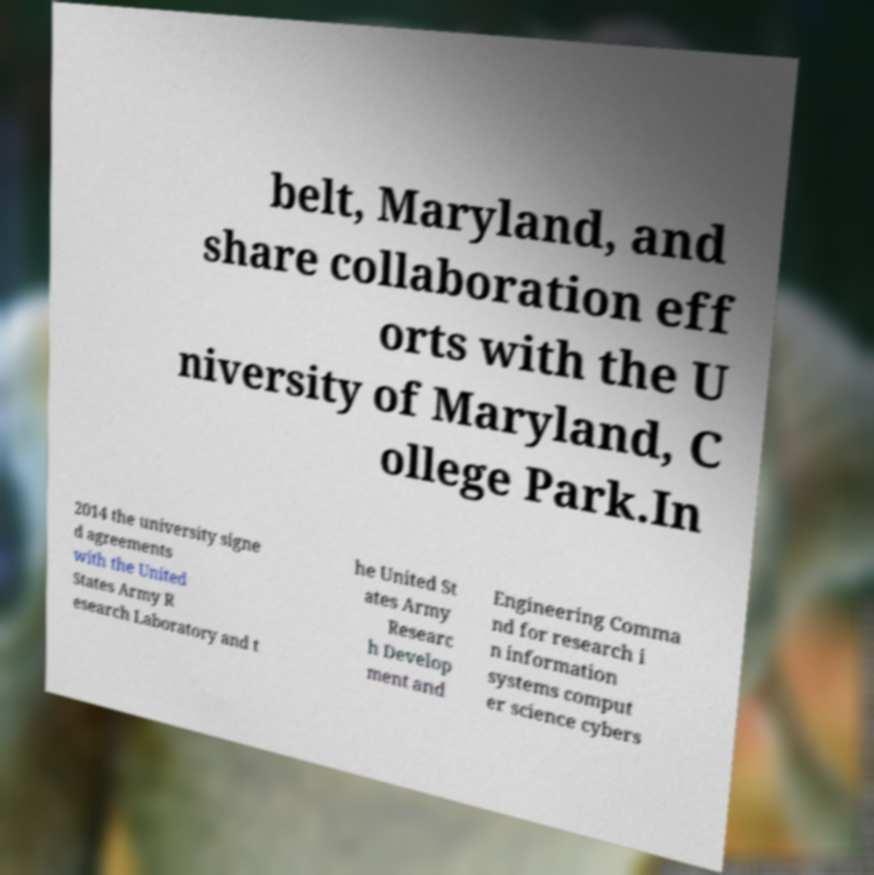There's text embedded in this image that I need extracted. Can you transcribe it verbatim? belt, Maryland, and share collaboration eff orts with the U niversity of Maryland, C ollege Park.In 2014 the university signe d agreements with the United States Army R esearch Laboratory and t he United St ates Army Researc h Develop ment and Engineering Comma nd for research i n information systems comput er science cybers 